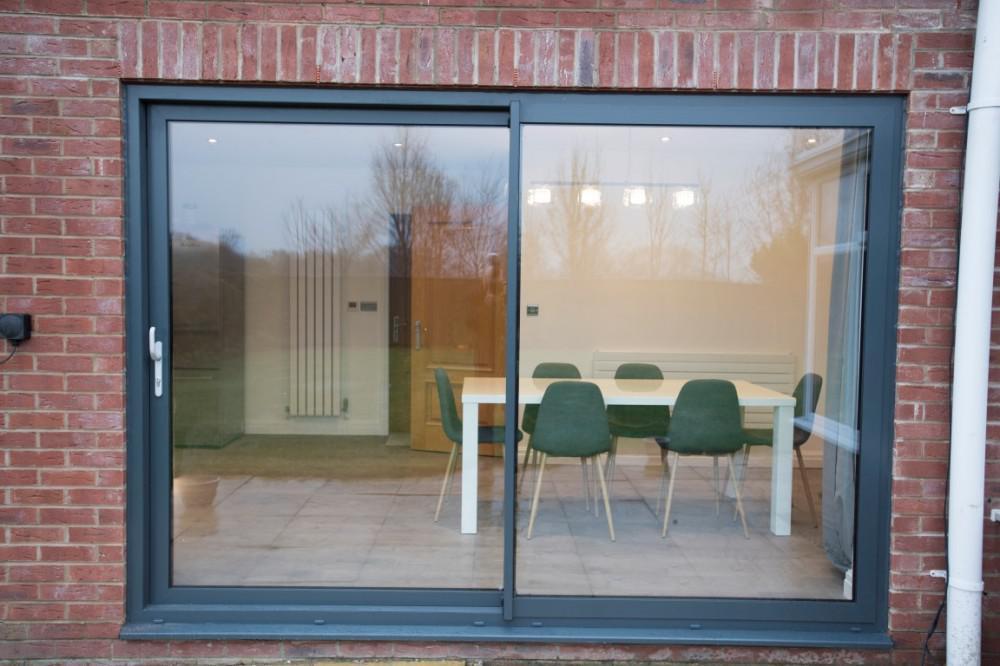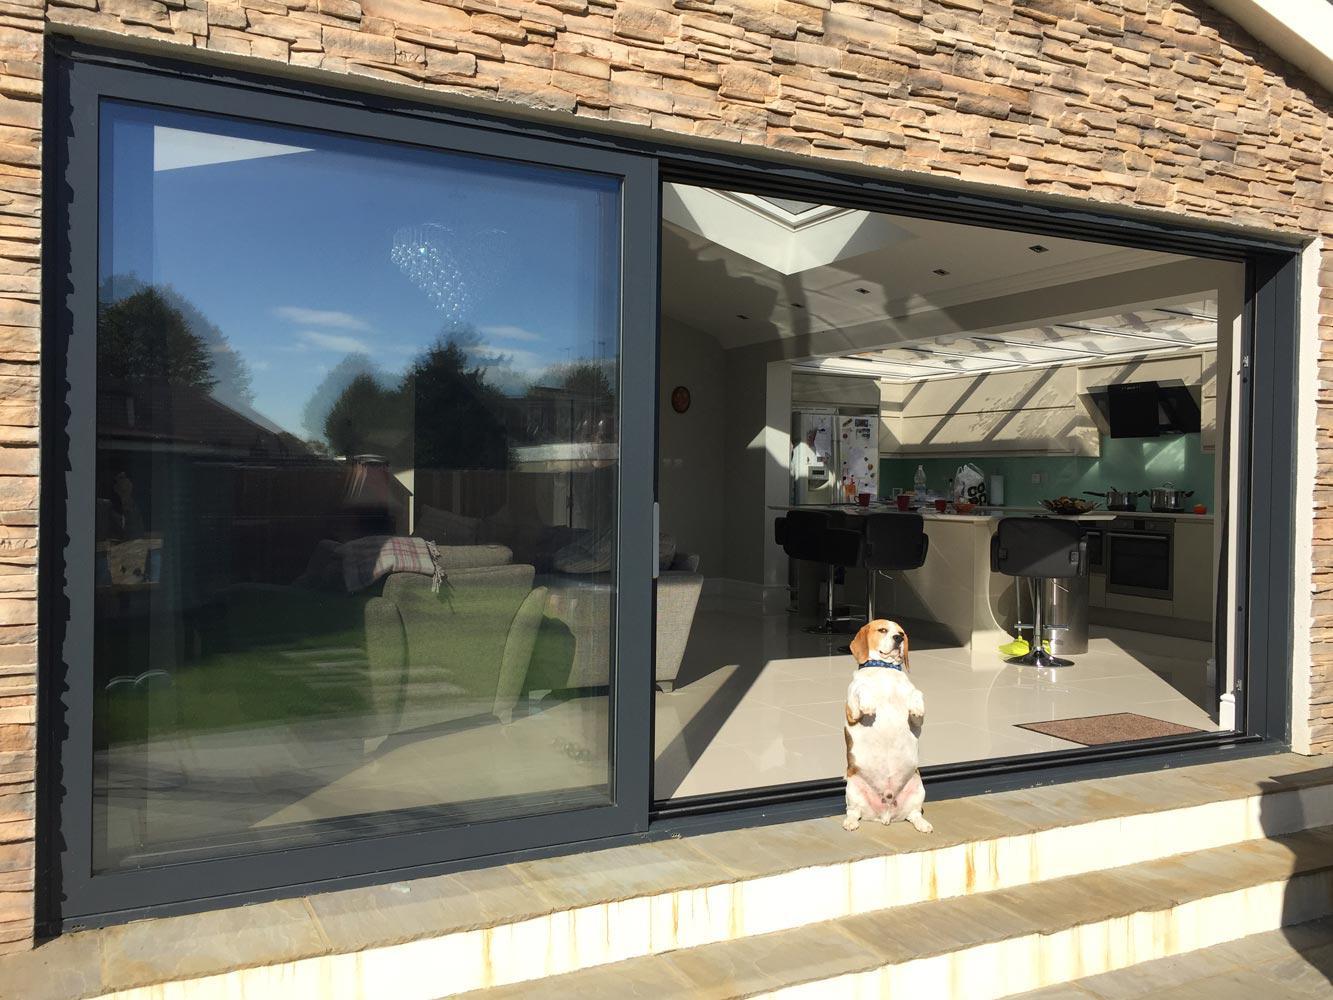The first image is the image on the left, the second image is the image on the right. For the images shown, is this caption "One door is open and one is closed." true? Answer yes or no. Yes. 